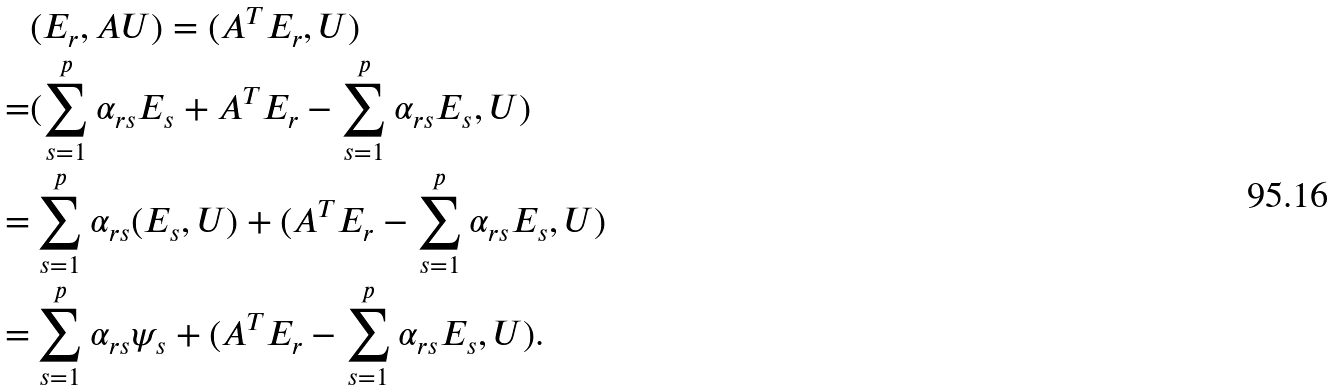Convert formula to latex. <formula><loc_0><loc_0><loc_500><loc_500>& ( E _ { r } , A U ) = ( A ^ { T } E _ { r } , U ) \\ = & ( \sum _ { s = 1 } ^ { p } \alpha _ { r s } E _ { s } + A ^ { T } E _ { r } - \sum _ { s = 1 } ^ { p } \alpha _ { r s } E _ { s } , U ) \\ = & \sum _ { s = 1 } ^ { p } \alpha _ { r s } ( E _ { s } , U ) + ( A ^ { T } E _ { r } - \sum _ { s = 1 } ^ { p } \alpha _ { r s } E _ { s } , U ) \\ = & \sum _ { s = 1 } ^ { p } \alpha _ { r s } \psi _ { s } + ( A ^ { T } E _ { r } - \sum _ { s = 1 } ^ { p } \alpha _ { r s } E _ { s } , U ) .</formula> 